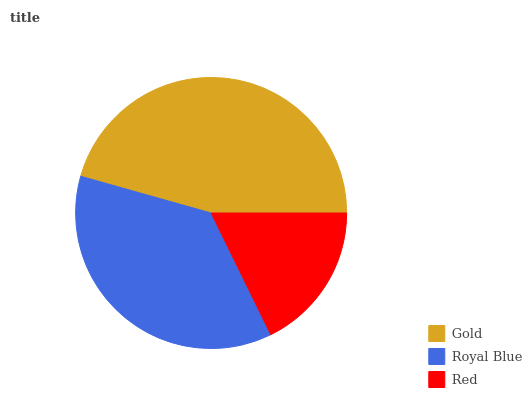Is Red the minimum?
Answer yes or no. Yes. Is Gold the maximum?
Answer yes or no. Yes. Is Royal Blue the minimum?
Answer yes or no. No. Is Royal Blue the maximum?
Answer yes or no. No. Is Gold greater than Royal Blue?
Answer yes or no. Yes. Is Royal Blue less than Gold?
Answer yes or no. Yes. Is Royal Blue greater than Gold?
Answer yes or no. No. Is Gold less than Royal Blue?
Answer yes or no. No. Is Royal Blue the high median?
Answer yes or no. Yes. Is Royal Blue the low median?
Answer yes or no. Yes. Is Gold the high median?
Answer yes or no. No. Is Red the low median?
Answer yes or no. No. 